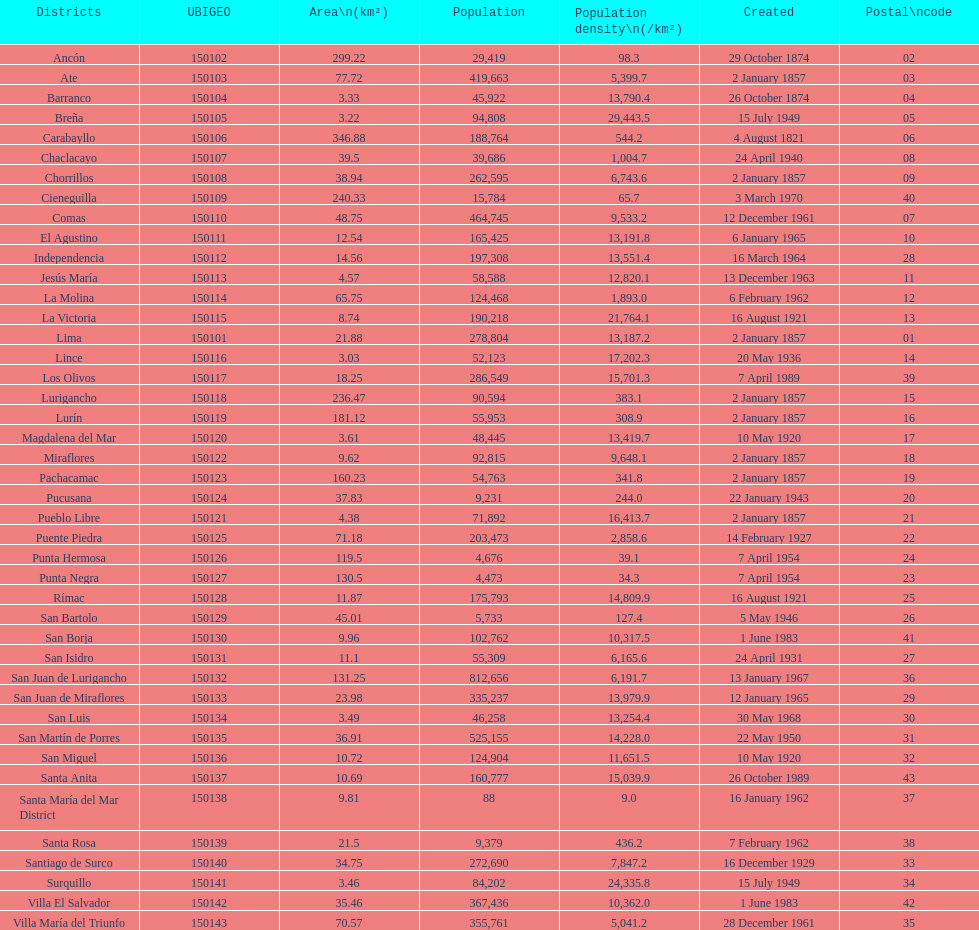Which is the largest district in terms of population? San Juan de Lurigancho. 